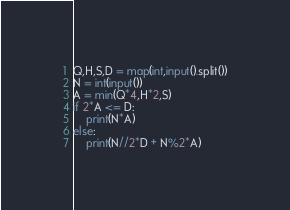<code> <loc_0><loc_0><loc_500><loc_500><_Python_>Q,H,S,D = map(int,input().split())
N = int(input())
A = min(Q*4,H*2,S)
if 2*A <= D:
    print(N*A)
else:
    print(N//2*D + N%2*A)
</code> 